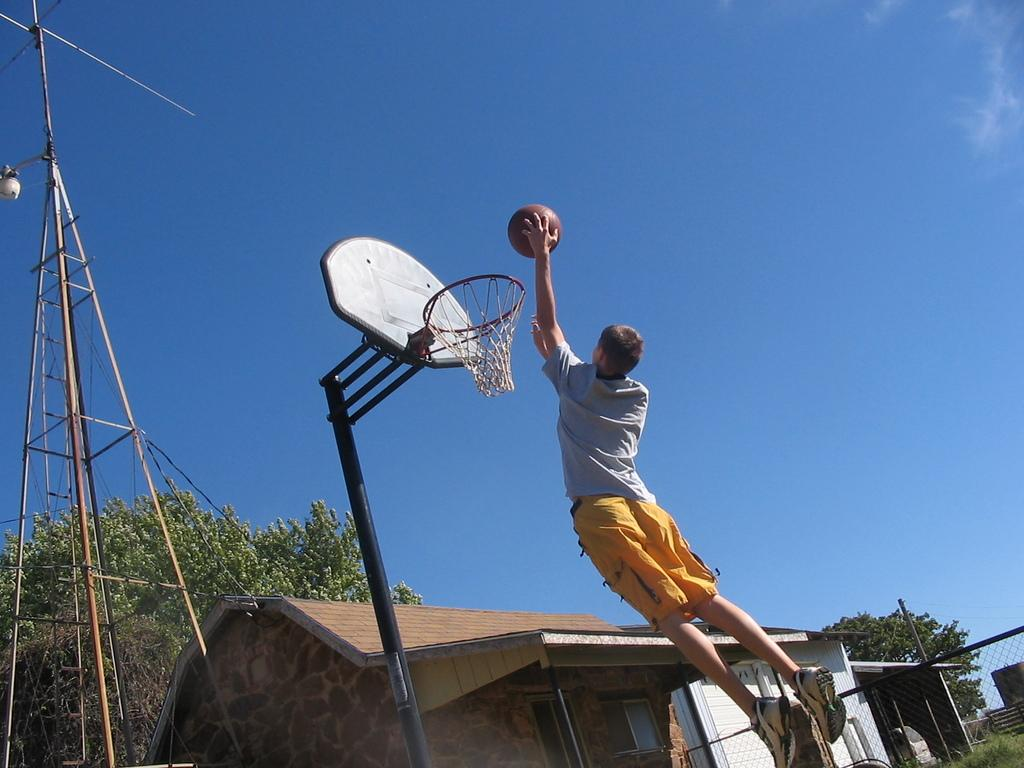What is located in the foreground of the image? In the foreground of the image, there is a person, a ball, a goal net, and a tower. What can be seen in the background of the image? In the background of the image, there are houses, grass, trees, and the sky. What time of day might the image have been taken? The image is likely taken during the day, as the sky is visible and there is no indication of darkness. What type of bean is being crushed by the person in the image? There is no bean present in the image, nor is anyone crushing a bean. 